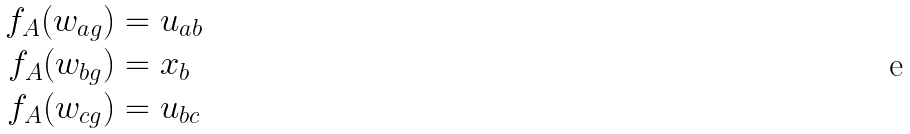<formula> <loc_0><loc_0><loc_500><loc_500>f _ { A } ( w _ { a g } ) & = u _ { a b } \\ f _ { A } ( w _ { b g } ) & = x _ { b } \\ f _ { A } ( w _ { c g } ) & = u _ { b c }</formula> 